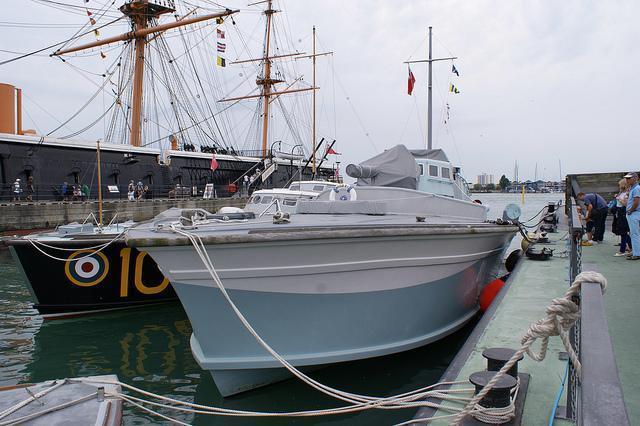What are the people ready to do?
Pick the right solution, then justify: 'Answer: answer
Rationale: rationale.'
Options: Eat, run, deplane, board. Answer: board.
Rationale: The people are standing on the dock waiting to get on board the boat that is waiting there. 